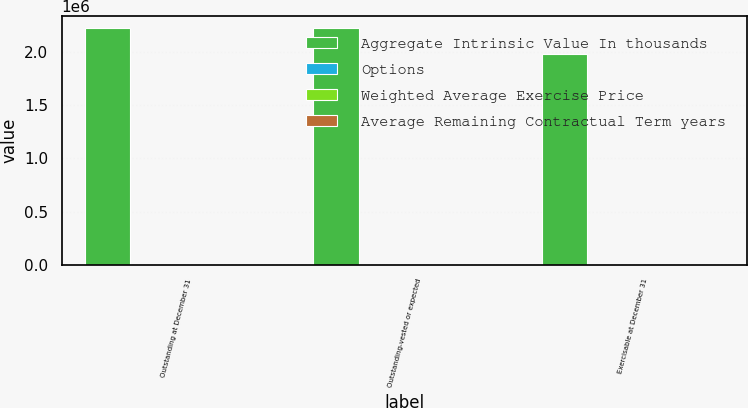<chart> <loc_0><loc_0><loc_500><loc_500><stacked_bar_chart><ecel><fcel>Outstanding at December 31<fcel>Outstanding-vested or expected<fcel>Exercisable at December 31<nl><fcel>Aggregate Intrinsic Value In thousands<fcel>2.22703e+06<fcel>2.22124e+06<fcel>1.98046e+06<nl><fcel>Options<fcel>19.85<fcel>19.84<fcel>19.36<nl><fcel>Weighted Average Exercise Price<fcel>4.1<fcel>4<fcel>3.9<nl><fcel>Average Remaining Contractual Term years<fcel>1132<fcel>1132<fcel>1132<nl></chart> 